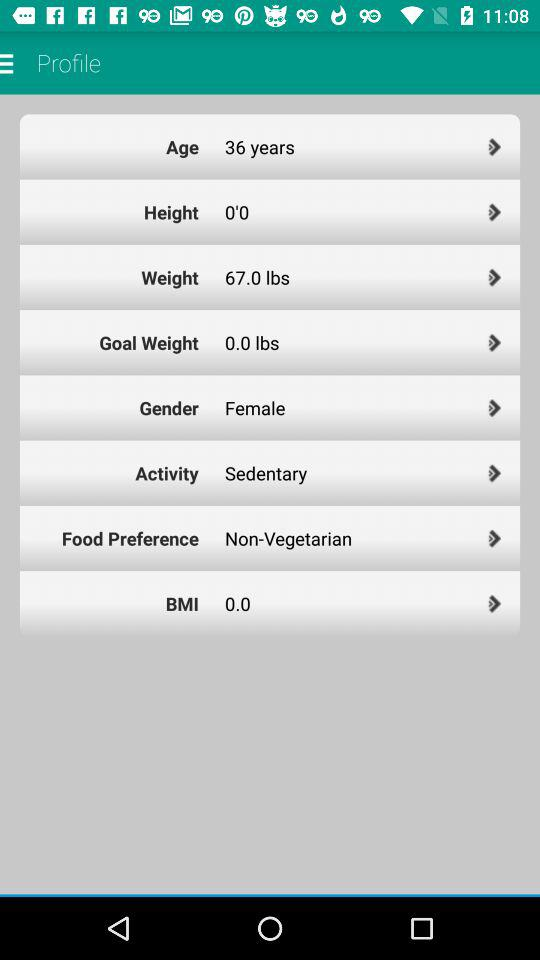What is the mentioned age of the person? The age of the person is 36 years. 